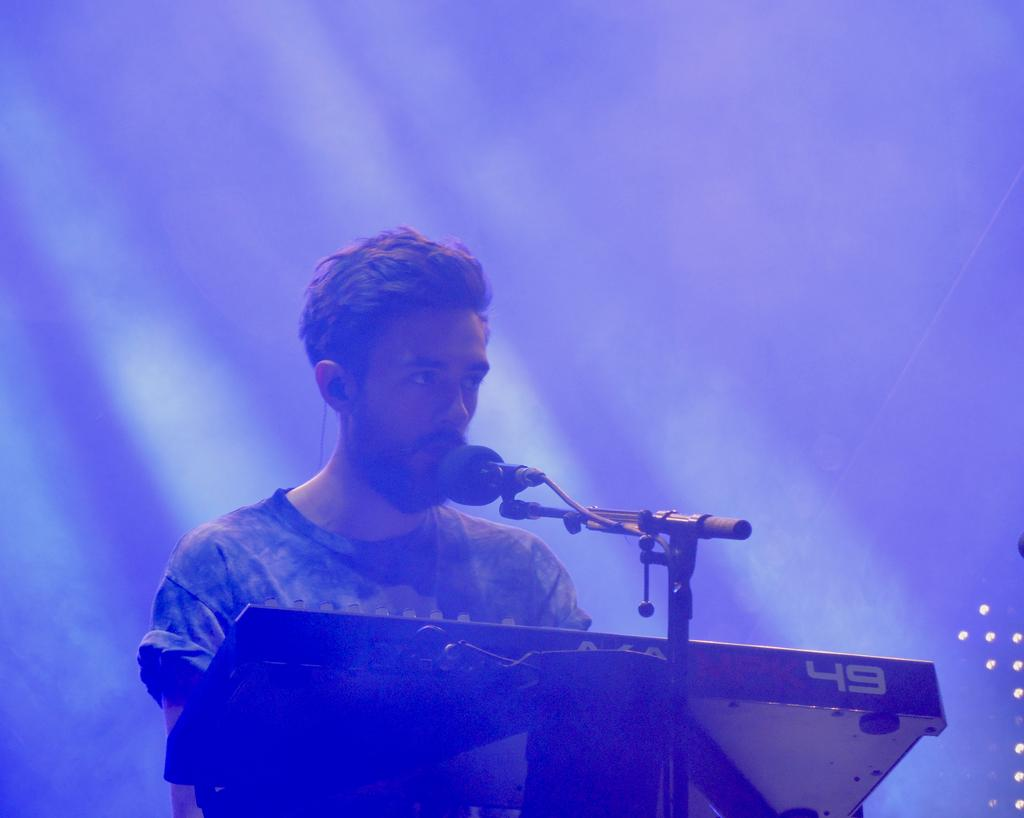Who or what is present in the image? There is a person in the image. What object is associated with the person in the image? There is a microphone with a microphone stand in the image. What other item can be seen in the image? There is a musical instrument in the image. What can be seen in the background of the image? There are lights visible in the background of the image. What type of pest can be seen crawling on the musical instrument in the image? There is no pest visible on the musical instrument in the image. In which country was the image taken? The provided facts do not give any information about the country where the image was taken. 